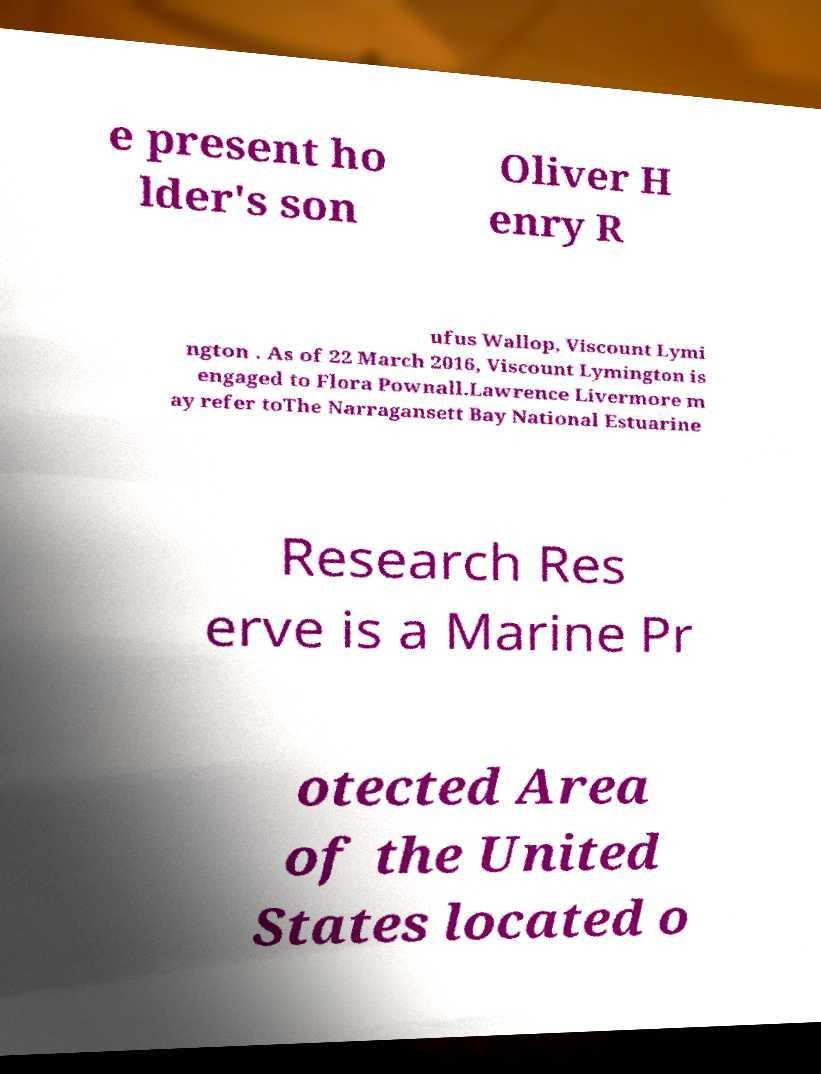Can you accurately transcribe the text from the provided image for me? e present ho lder's son Oliver H enry R ufus Wallop, Viscount Lymi ngton . As of 22 March 2016, Viscount Lymington is engaged to Flora Pownall.Lawrence Livermore m ay refer toThe Narragansett Bay National Estuarine Research Res erve is a Marine Pr otected Area of the United States located o 